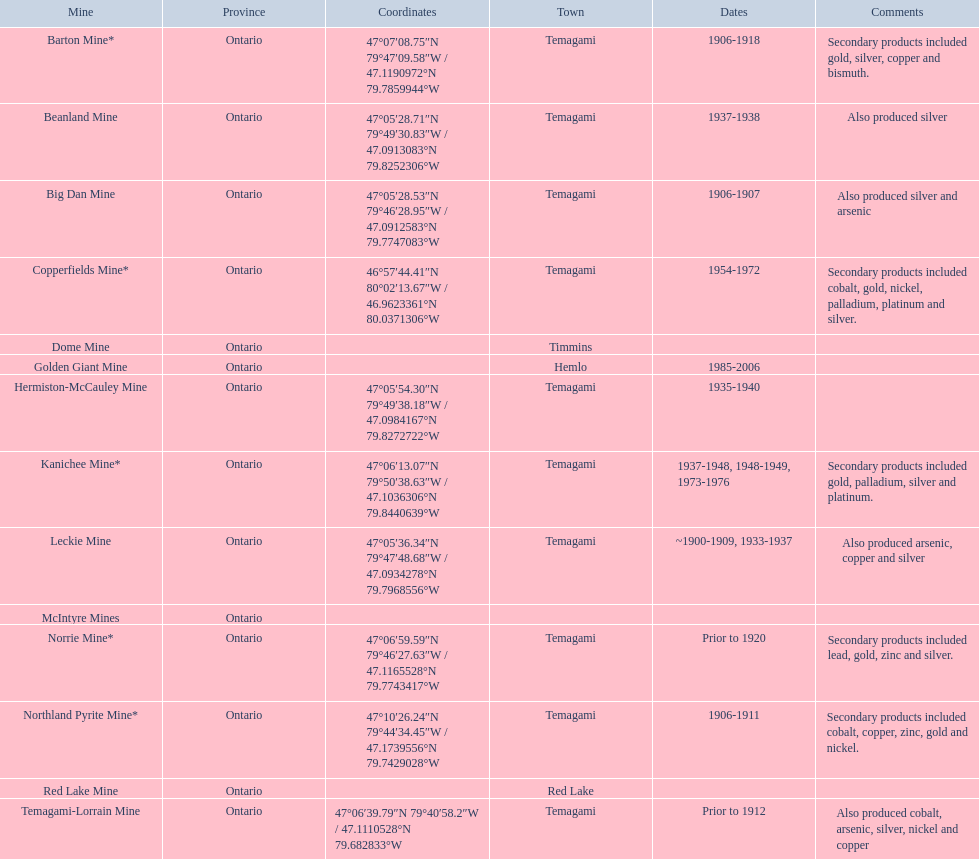What were the operational years for the golden giant mine? 1985-2006. What years was the beanland mine open for production? 1937-1938. Can you give me this table in json format? {'header': ['Mine', 'Province', 'Coordinates', 'Town', 'Dates', 'Comments'], 'rows': [['Barton Mine*', 'Ontario', '47°07′08.75″N 79°47′09.58″W\ufeff / \ufeff47.1190972°N 79.7859944°W', 'Temagami', '1906-1918', 'Secondary products included gold, silver, copper and bismuth.'], ['Beanland Mine', 'Ontario', '47°05′28.71″N 79°49′30.83″W\ufeff / \ufeff47.0913083°N 79.8252306°W', 'Temagami', '1937-1938', 'Also produced silver'], ['Big Dan Mine', 'Ontario', '47°05′28.53″N 79°46′28.95″W\ufeff / \ufeff47.0912583°N 79.7747083°W', 'Temagami', '1906-1907', 'Also produced silver and arsenic'], ['Copperfields Mine*', 'Ontario', '46°57′44.41″N 80°02′13.67″W\ufeff / \ufeff46.9623361°N 80.0371306°W', 'Temagami', '1954-1972', 'Secondary products included cobalt, gold, nickel, palladium, platinum and silver.'], ['Dome Mine', 'Ontario', '', 'Timmins', '', ''], ['Golden Giant Mine', 'Ontario', '', 'Hemlo', '1985-2006', ''], ['Hermiston-McCauley Mine', 'Ontario', '47°05′54.30″N 79°49′38.18″W\ufeff / \ufeff47.0984167°N 79.8272722°W', 'Temagami', '1935-1940', ''], ['Kanichee Mine*', 'Ontario', '47°06′13.07″N 79°50′38.63″W\ufeff / \ufeff47.1036306°N 79.8440639°W', 'Temagami', '1937-1948, 1948-1949, 1973-1976', 'Secondary products included gold, palladium, silver and platinum.'], ['Leckie Mine', 'Ontario', '47°05′36.34″N 79°47′48.68″W\ufeff / \ufeff47.0934278°N 79.7968556°W', 'Temagami', '~1900-1909, 1933-1937', 'Also produced arsenic, copper and silver'], ['McIntyre Mines', 'Ontario', '', '', '', ''], ['Norrie Mine*', 'Ontario', '47°06′59.59″N 79°46′27.63″W\ufeff / \ufeff47.1165528°N 79.7743417°W', 'Temagami', 'Prior to 1920', 'Secondary products included lead, gold, zinc and silver.'], ['Northland Pyrite Mine*', 'Ontario', '47°10′26.24″N 79°44′34.45″W\ufeff / \ufeff47.1739556°N 79.7429028°W', 'Temagami', '1906-1911', 'Secondary products included cobalt, copper, zinc, gold and nickel.'], ['Red Lake Mine', 'Ontario', '', 'Red Lake', '', ''], ['Temagami-Lorrain Mine', 'Ontario', '47°06′39.79″N 79°40′58.2″W\ufeff / \ufeff47.1110528°N 79.682833°W', 'Temagami', 'Prior to 1912', 'Also produced cobalt, arsenic, silver, nickel and copper']]} Out of these two mines, which one was open for a longer time? Golden Giant Mine. 